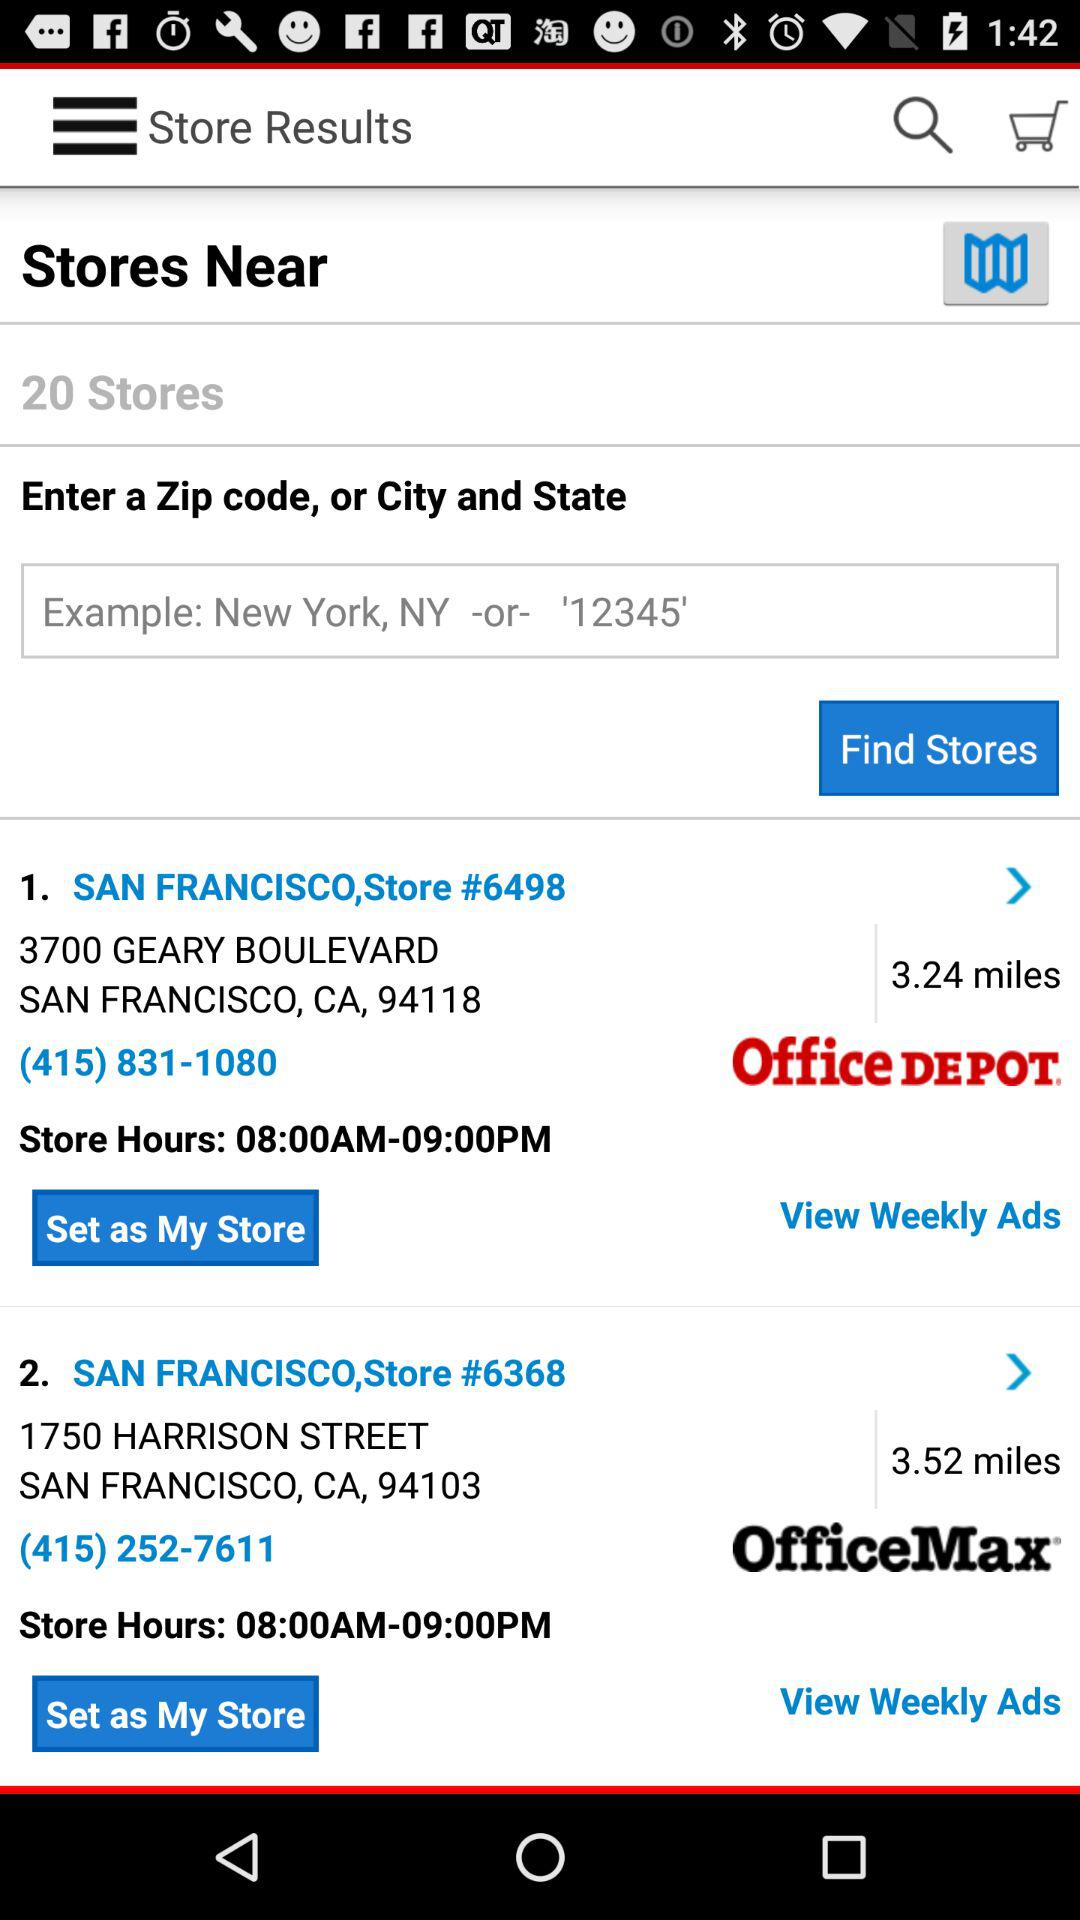What is the contact number for San Francisco, store #6498? The contact number is (415) 831-1080. 